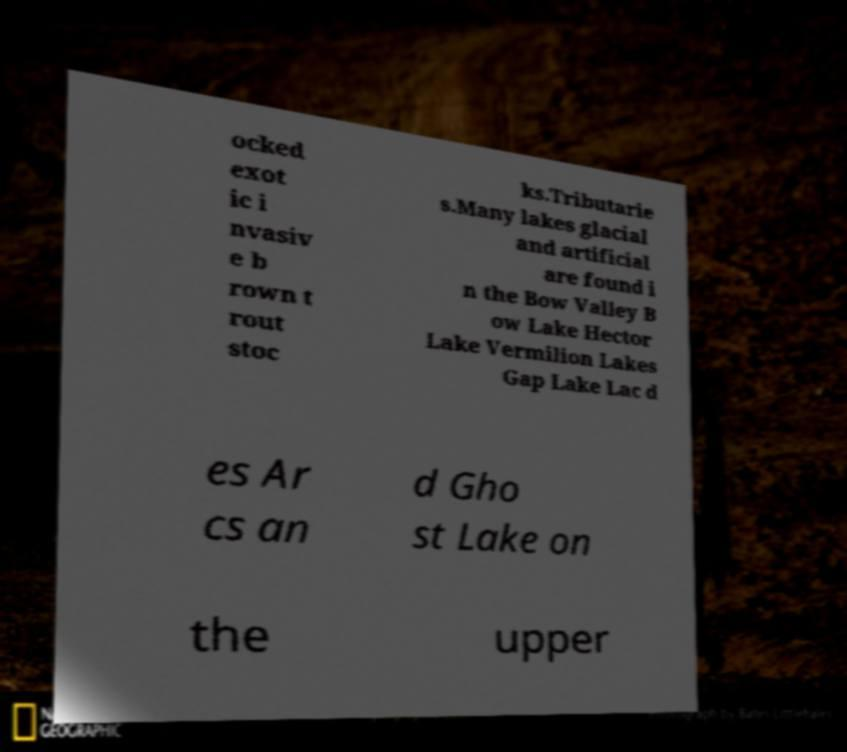For documentation purposes, I need the text within this image transcribed. Could you provide that? ocked exot ic i nvasiv e b rown t rout stoc ks.Tributarie s.Many lakes glacial and artificial are found i n the Bow Valley B ow Lake Hector Lake Vermilion Lakes Gap Lake Lac d es Ar cs an d Gho st Lake on the upper 